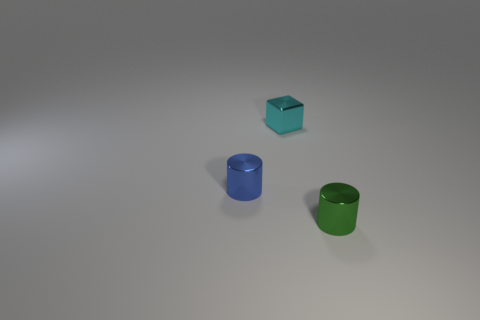What is the size of the metallic thing that is to the left of the tiny green thing and to the right of the small blue cylinder?
Provide a short and direct response. Small. How many small gray metal things are there?
Your answer should be very brief. 0. How many cubes are either blue things or small things?
Your response must be concise. 1. There is a small metallic object behind the tiny metal cylinder behind the green metal cylinder; how many tiny metallic objects are to the left of it?
Make the answer very short. 1. The cylinder that is the same size as the blue thing is what color?
Your answer should be very brief. Green. What number of other things are there of the same color as the small shiny cube?
Your response must be concise. 0. Are there more tiny cyan things to the right of the tiny blue object than large blue rubber cubes?
Provide a succinct answer. Yes. Is the material of the tiny cube the same as the blue cylinder?
Offer a terse response. Yes. How many things are tiny shiny objects on the left side of the tiny cube or big brown things?
Ensure brevity in your answer.  1. Is the number of blue cylinders in front of the green object the same as the number of tiny cylinders in front of the blue cylinder?
Provide a succinct answer. No. 